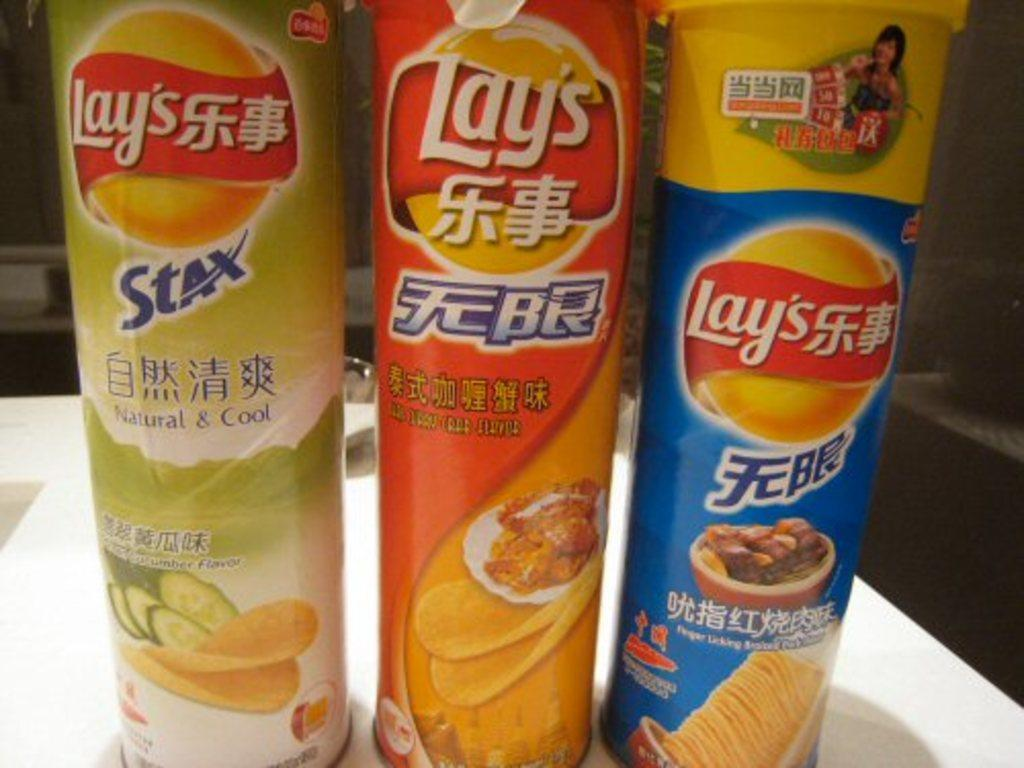How many food item packets are visible in the image? There are three food item packets in the image. Where are the food item packets located? The food item packets are in a pipe-like structure. What is the structure placed on? The structure is on a table. Can you describe the background of the image? The image is not clear, but there are objects visible in the background. What type of whistle can be heard coming from the giraffe in the image? There is no giraffe or whistle present in the image. Is there a blade visible in the image? There is no blade visible in the image. 